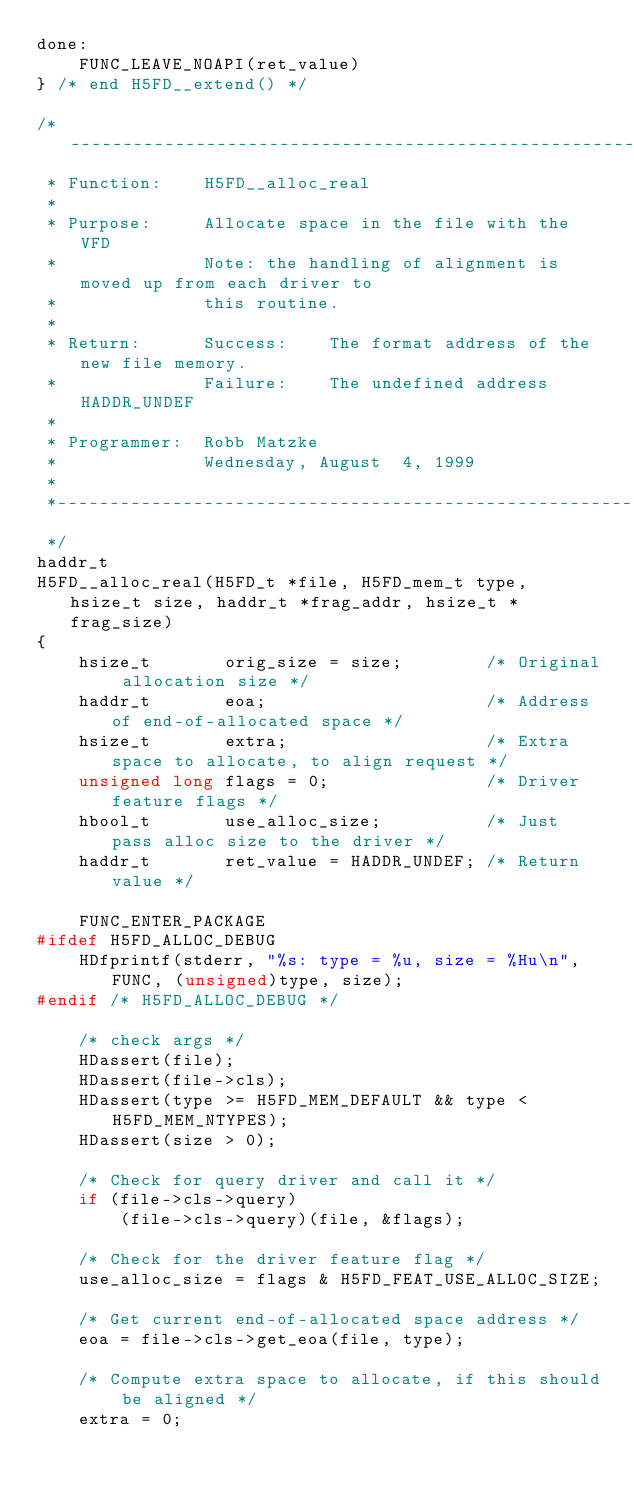<code> <loc_0><loc_0><loc_500><loc_500><_C_>done:
    FUNC_LEAVE_NOAPI(ret_value)
} /* end H5FD__extend() */

/*-------------------------------------------------------------------------
 * Function:    H5FD__alloc_real
 *
 * Purpose:     Allocate space in the file with the VFD
 *              Note: the handling of alignment is moved up from each driver to
 *              this routine.
 *
 * Return:      Success:    The format address of the new file memory.
 *              Failure:    The undefined address HADDR_UNDEF
 *
 * Programmer:  Robb Matzke
 *              Wednesday, August  4, 1999
 *
 *-------------------------------------------------------------------------
 */
haddr_t
H5FD__alloc_real(H5FD_t *file, H5FD_mem_t type, hsize_t size, haddr_t *frag_addr, hsize_t *frag_size)
{
    hsize_t       orig_size = size;        /* Original allocation size */
    haddr_t       eoa;                     /* Address of end-of-allocated space */
    hsize_t       extra;                   /* Extra space to allocate, to align request */
    unsigned long flags = 0;               /* Driver feature flags */
    hbool_t       use_alloc_size;          /* Just pass alloc size to the driver */
    haddr_t       ret_value = HADDR_UNDEF; /* Return value */

    FUNC_ENTER_PACKAGE
#ifdef H5FD_ALLOC_DEBUG
    HDfprintf(stderr, "%s: type = %u, size = %Hu\n", FUNC, (unsigned)type, size);
#endif /* H5FD_ALLOC_DEBUG */

    /* check args */
    HDassert(file);
    HDassert(file->cls);
    HDassert(type >= H5FD_MEM_DEFAULT && type < H5FD_MEM_NTYPES);
    HDassert(size > 0);

    /* Check for query driver and call it */
    if (file->cls->query)
        (file->cls->query)(file, &flags);

    /* Check for the driver feature flag */
    use_alloc_size = flags & H5FD_FEAT_USE_ALLOC_SIZE;

    /* Get current end-of-allocated space address */
    eoa = file->cls->get_eoa(file, type);

    /* Compute extra space to allocate, if this should be aligned */
    extra = 0;</code> 